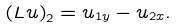Convert formula to latex. <formula><loc_0><loc_0><loc_500><loc_500>\left ( L u \right ) _ { 2 } = u _ { 1 y } - u _ { 2 x } .</formula> 